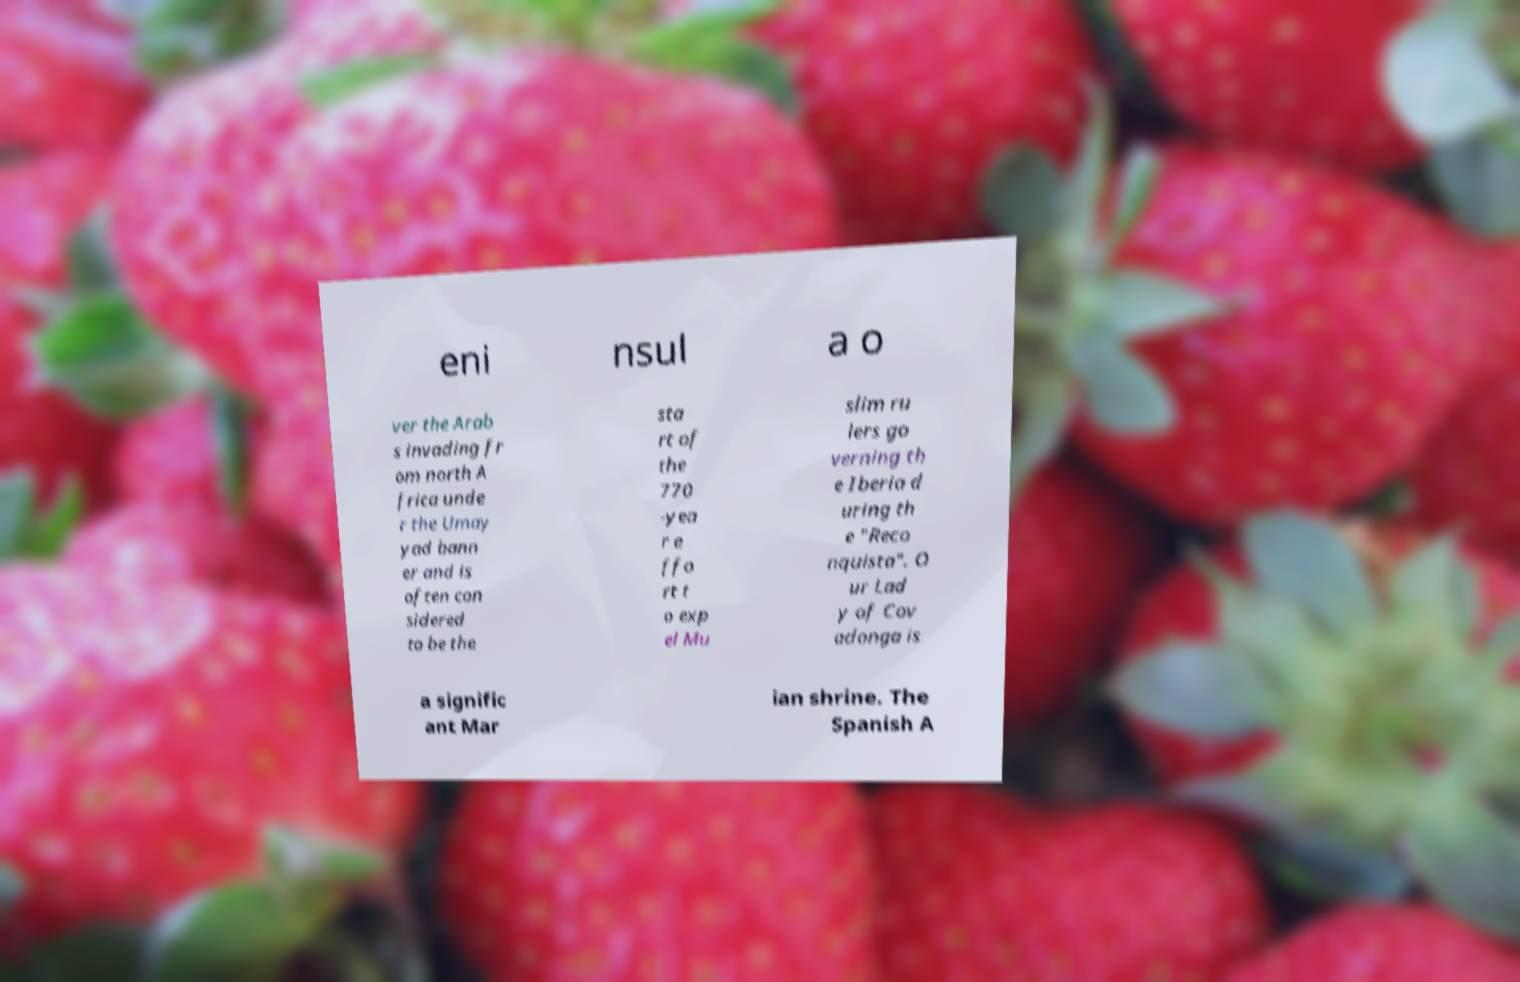Could you assist in decoding the text presented in this image and type it out clearly? eni nsul a o ver the Arab s invading fr om north A frica unde r the Umay yad bann er and is often con sidered to be the sta rt of the 770 -yea r e ffo rt t o exp el Mu slim ru lers go verning th e Iberia d uring th e "Reco nquista". O ur Lad y of Cov adonga is a signific ant Mar ian shrine. The Spanish A 